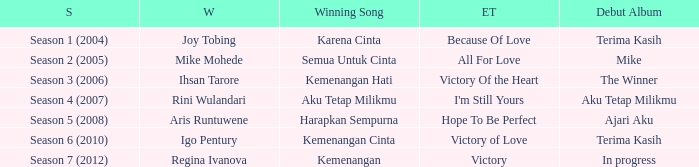Who won with the song kemenangan cinta? Igo Pentury. 